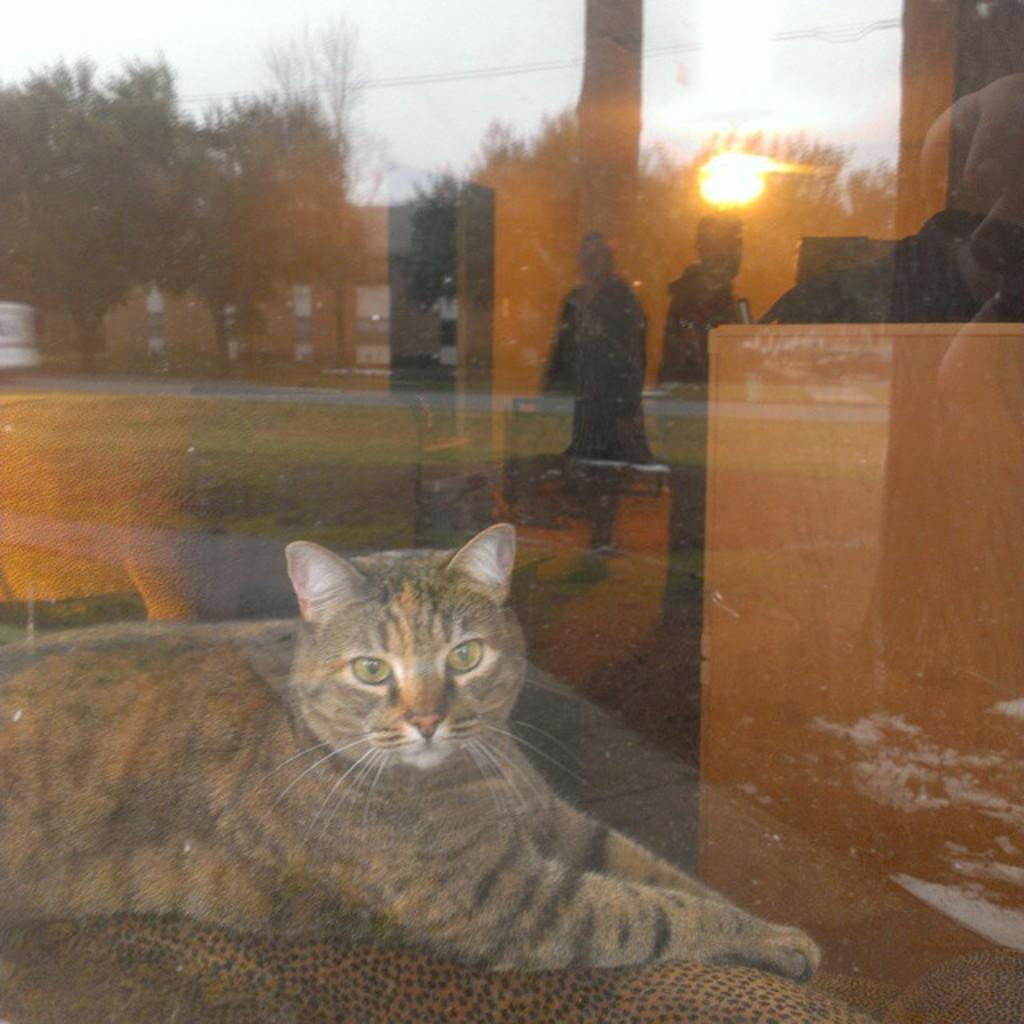What animal can be seen sitting in the image? There is a cat sitting in the image. What type of door is visible in the image? The image appears to show a glass door. What can be seen in the reflection of the glass door? The reflection of trees and buildings is visible in the glass door. How many people are standing, as seen in the reflection? Two people are standing, as seen in the reflection. What type of vegetation is visible in the image? There is grass visible in the image. What is visible in the sky in the image? The sun is visible in the sky. What type of baseball equipment can be seen in the image? There is no baseball equipment present in the image. Can you describe the detail of the tiger's fur in the image? There is no tiger present in the image, so it is not possible to describe the detail of its fur. 